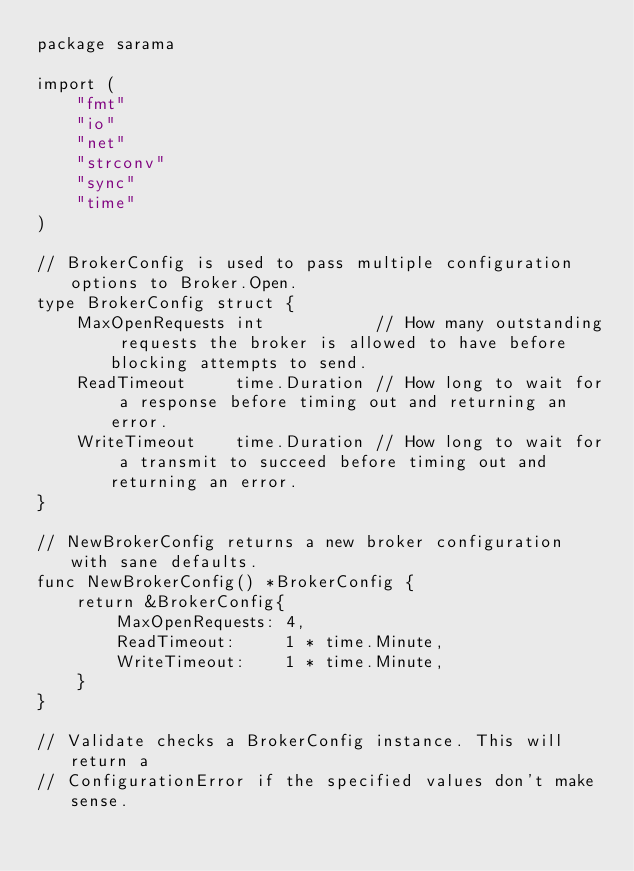Convert code to text. <code><loc_0><loc_0><loc_500><loc_500><_Go_>package sarama

import (
	"fmt"
	"io"
	"net"
	"strconv"
	"sync"
	"time"
)

// BrokerConfig is used to pass multiple configuration options to Broker.Open.
type BrokerConfig struct {
	MaxOpenRequests int           // How many outstanding requests the broker is allowed to have before blocking attempts to send.
	ReadTimeout     time.Duration // How long to wait for a response before timing out and returning an error.
	WriteTimeout    time.Duration // How long to wait for a transmit to succeed before timing out and returning an error.
}

// NewBrokerConfig returns a new broker configuration with sane defaults.
func NewBrokerConfig() *BrokerConfig {
	return &BrokerConfig{
		MaxOpenRequests: 4,
		ReadTimeout:     1 * time.Minute,
		WriteTimeout:    1 * time.Minute,
	}
}

// Validate checks a BrokerConfig instance. This will return a
// ConfigurationError if the specified values don't make sense.</code> 